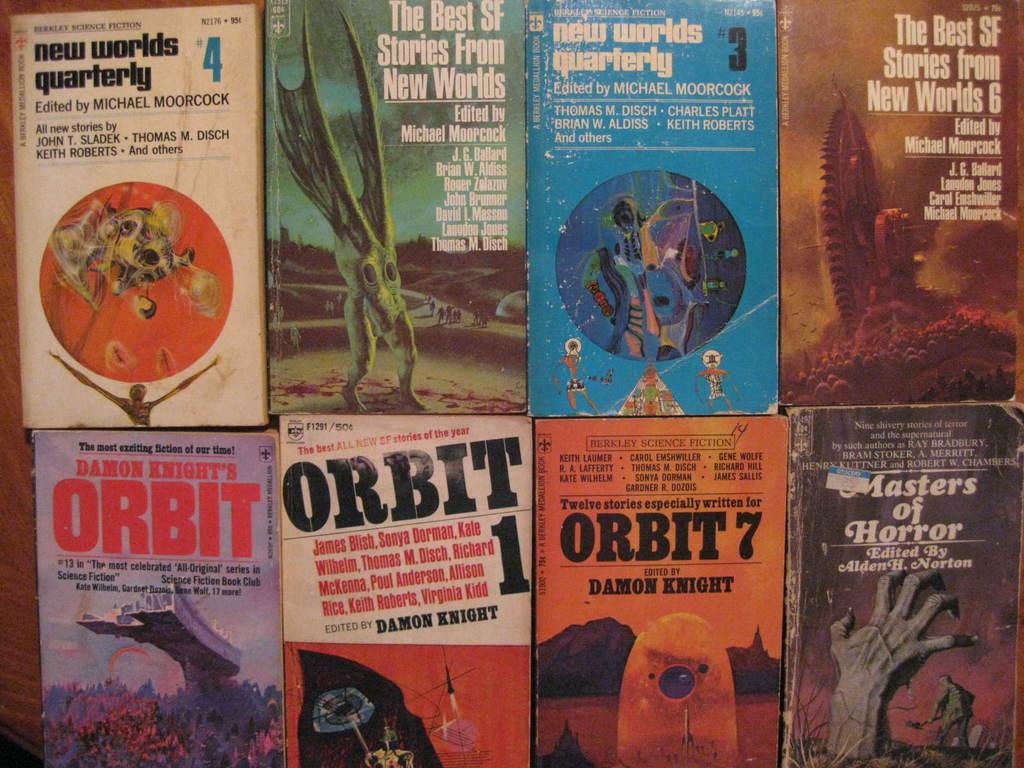<image>
Offer a succinct explanation of the picture presented. Two rows of paperback books are displayed beginning with the title, "New World Quarterly." 